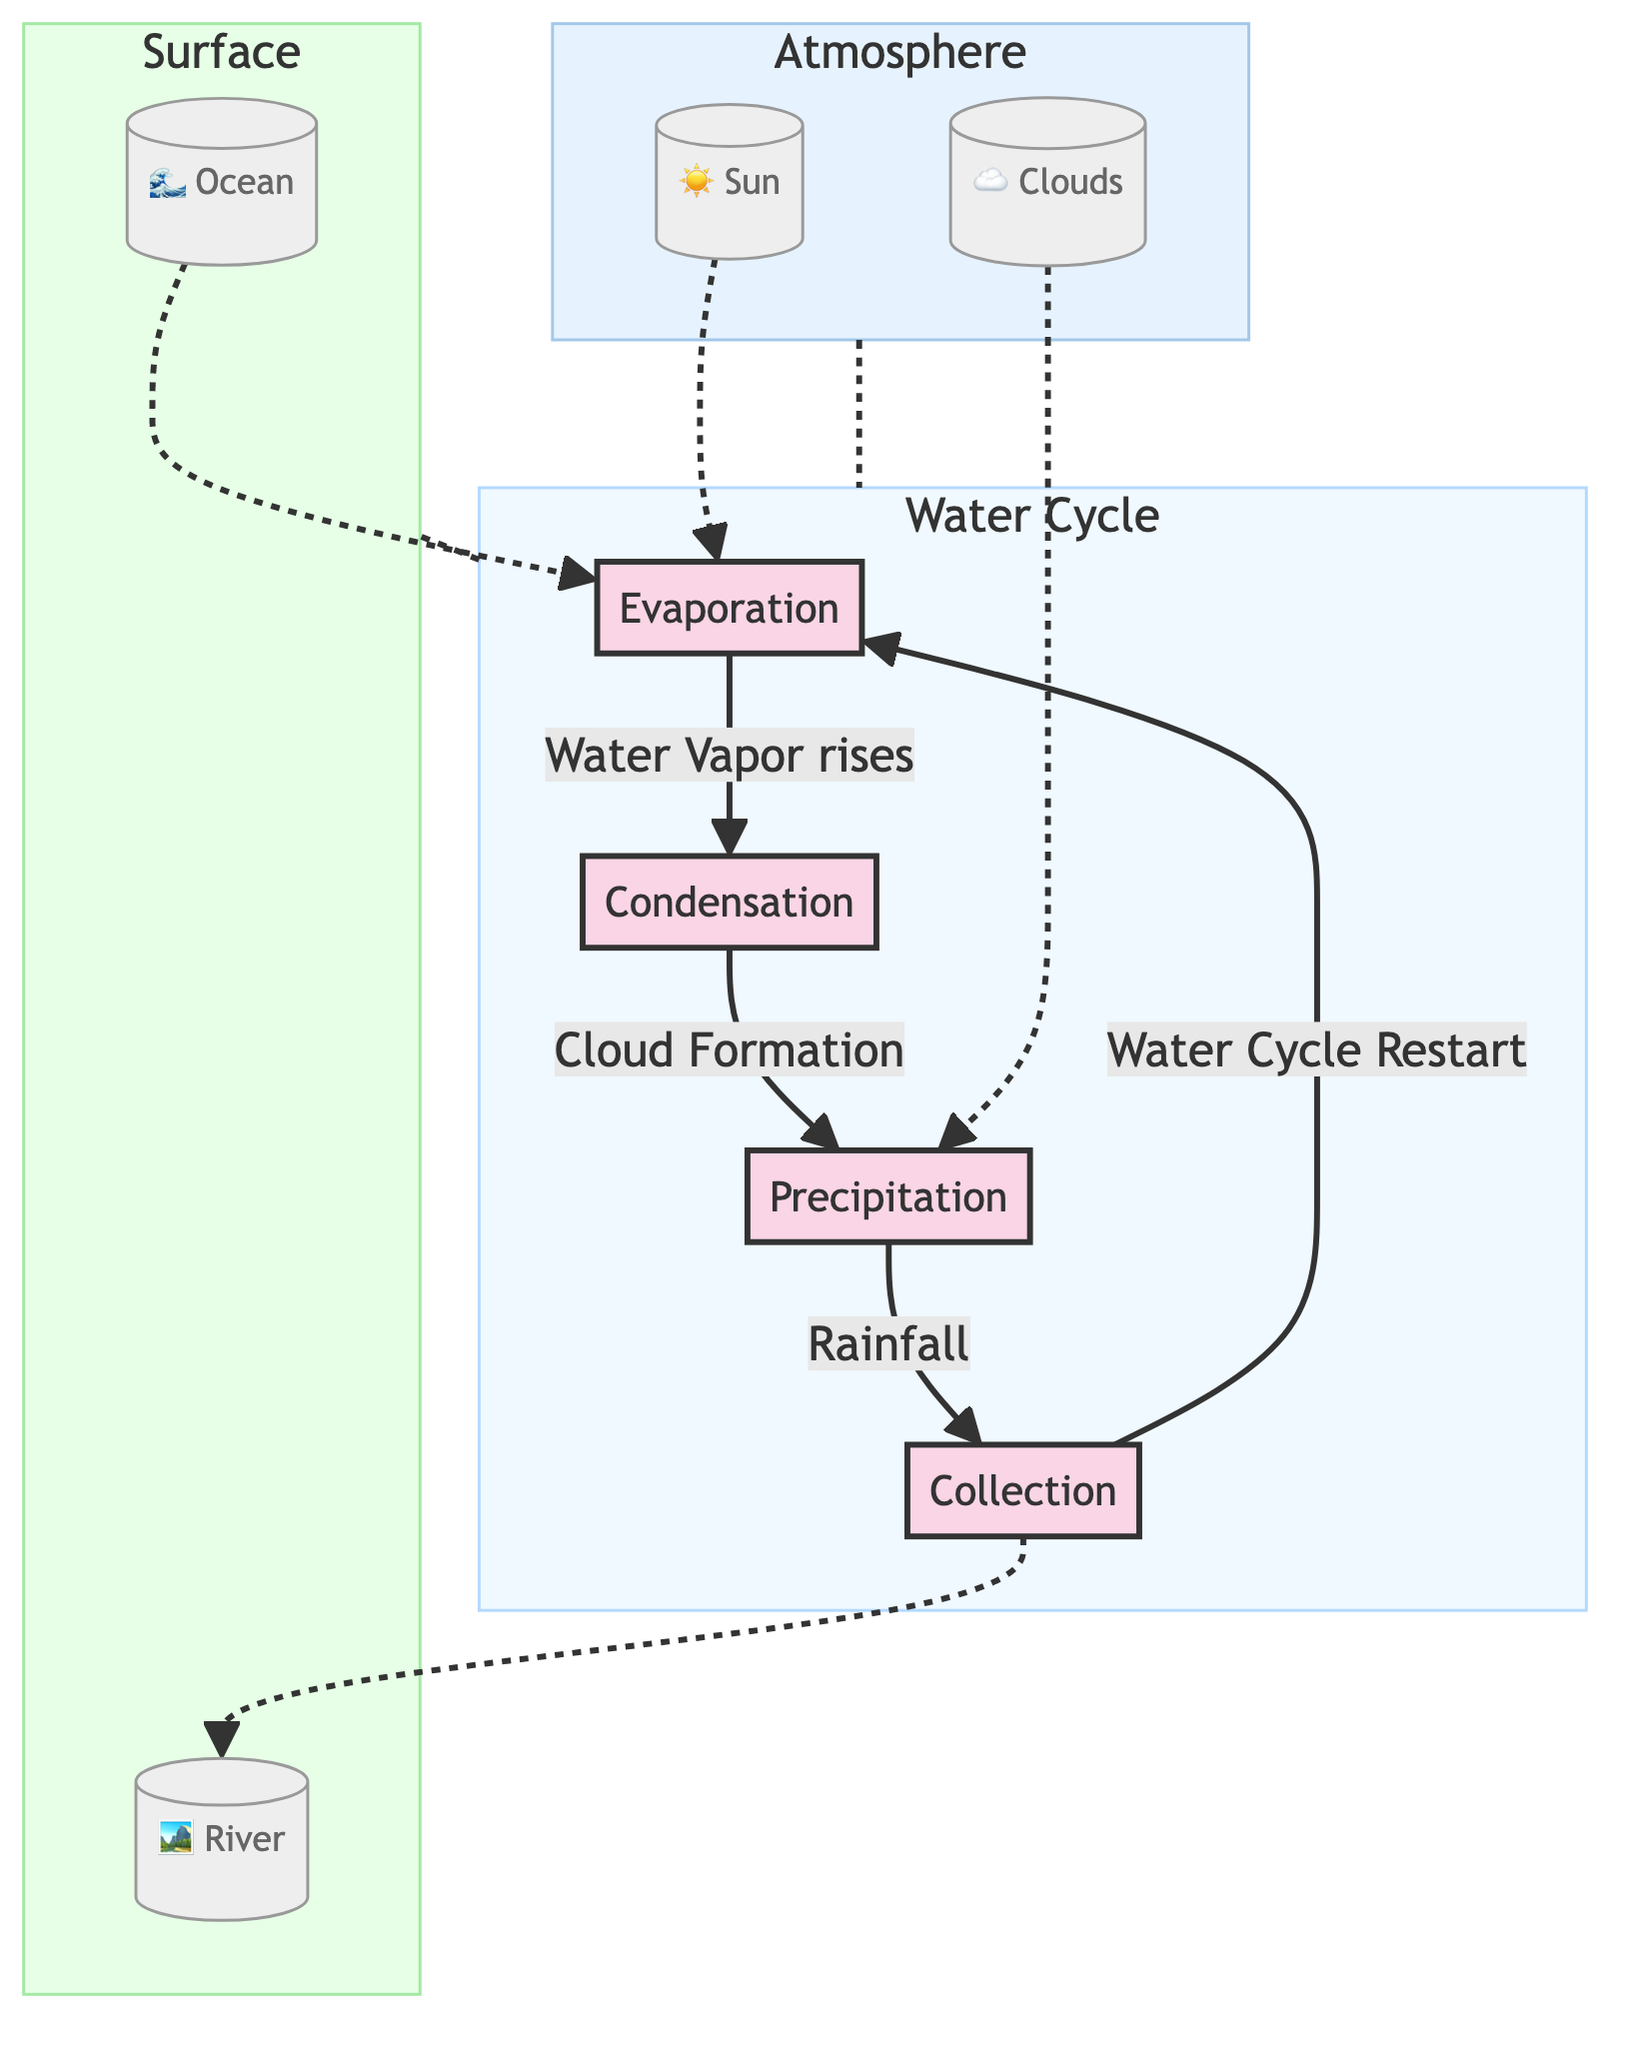What are the four main stages of the water cycle depicted in the diagram? The diagram clearly outlines four stages: Evaporation, Condensation, Precipitation, and Collection. These stages are represented as distinct nodes connected by directional arrows.
Answer: Evaporation, Condensation, Precipitation, Collection Which element is indicated to help initiate evaporation? The diagram specifies the Sun as the element that contributes to the evaporation process. The directional connection shows that the Sun influences Evaporation.
Answer: Sun How many elements are depicted in the Surface subsection? The Surface subsection contains two elements: Ocean and River. The diagram represents these elements with distinct nodes under the Surface subgraph.
Answer: 2 What process follows condensation in the water cycle? According to the flow in the diagram, after Condensation occurs, the next stage is Precipitation as indicated by the directed connection leading from Condensation to Precipitation.
Answer: Precipitation How does collection influence evaporation in the water cycle? The diagram indicates that Collection leads to Evaporation, as shown by the arrow pointing from Collection back to Evaporation suggesting that collected water can evaporate again.
Answer: Water Cycle Restart What natural feature is mentioned as a destination for collected water in the diagram? The diagram shows that water collected in the Collection stage can flow to the River, as indicated by the directional arrow leading from Collection to River.
Answer: River What role do clouds play in the water cycle according to the diagram? The diagram illustrates that Clouds are involved in Precipitation, indicated by the dotted arrow connecting Clouds to the Precipitation stage, signifying their role in the formation of rainfall.
Answer: Cloud Formation In what order do evaporation, condensation, precipitation, and collection occur? The diagram illustrates a continuous cycle starting from Evaporation, moving to Condensation, followed by Precipitation, and finally to Collection before returning to Evaporation. This sequence clearly shows the flow of the water cycle.
Answer: Evaporation, Condensation, Precipitation, Collection 